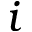Convert formula to latex. <formula><loc_0><loc_0><loc_500><loc_500>i</formula> 